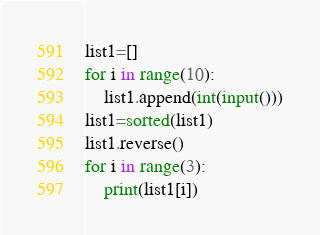Convert code to text. <code><loc_0><loc_0><loc_500><loc_500><_Python_>list1=[]
for i in range(10):
    list1.append(int(input()))
list1=sorted(list1)
list1.reverse()
for i in range(3):
    print(list1[i])</code> 